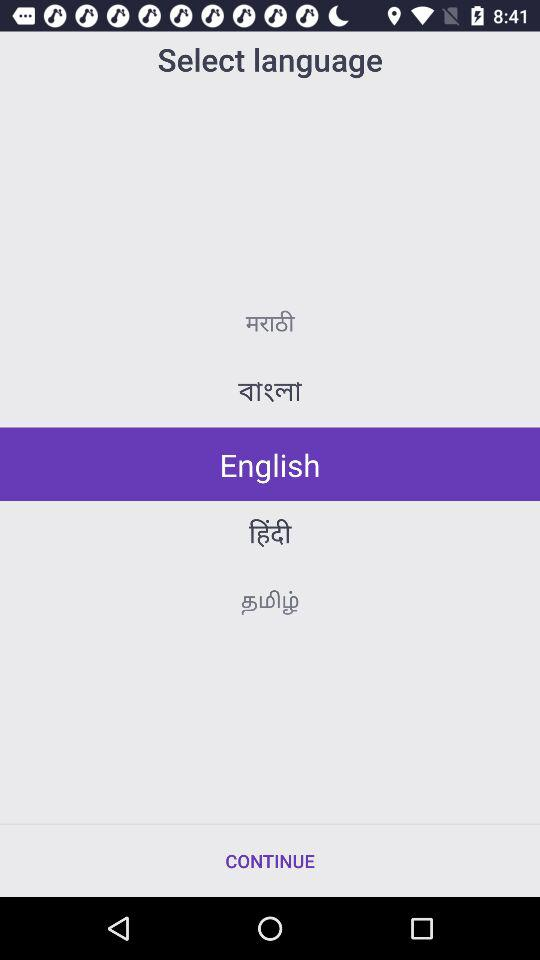Which language is selected? The selected language is English. 